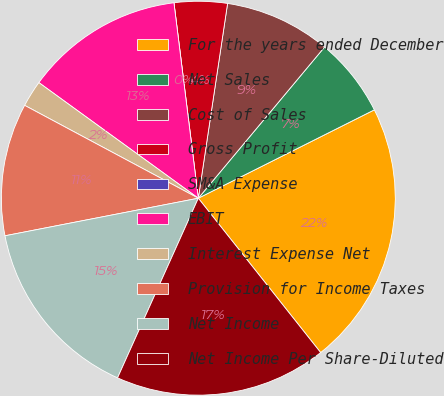<chart> <loc_0><loc_0><loc_500><loc_500><pie_chart><fcel>For the years ended December<fcel>Net Sales<fcel>Cost of Sales<fcel>Gross Profit<fcel>SM&A Expense<fcel>EBIT<fcel>Interest Expense Net<fcel>Provision for Income Taxes<fcel>Net Income<fcel>Net Income Per Share-Diluted<nl><fcel>21.74%<fcel>6.52%<fcel>8.7%<fcel>4.35%<fcel>0.0%<fcel>13.04%<fcel>2.17%<fcel>10.87%<fcel>15.22%<fcel>17.39%<nl></chart> 